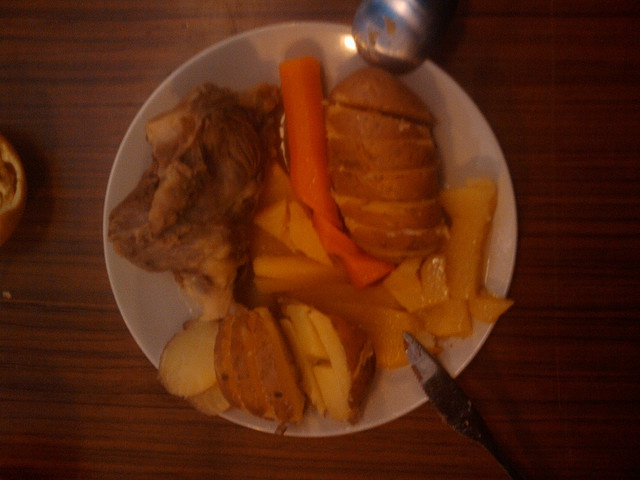Describe the objects in this image and their specific colors. I can see dining table in maroon, black, and brown tones, carrot in black, brown, and maroon tones, spoon in black, gray, and maroon tones, and knife in black, maroon, and brown tones in this image. 